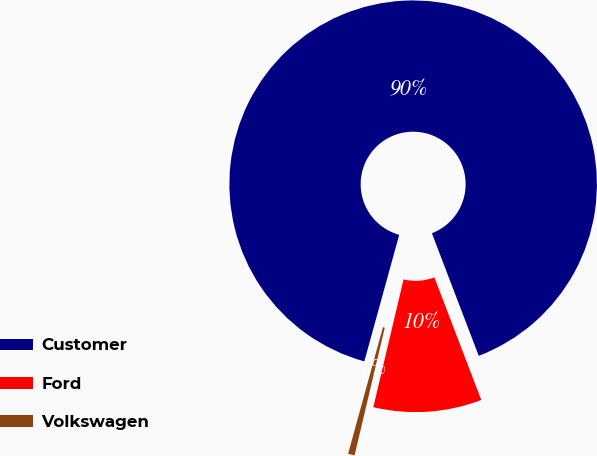Convert chart to OTSL. <chart><loc_0><loc_0><loc_500><loc_500><pie_chart><fcel>Customer<fcel>Ford<fcel>Volkswagen<nl><fcel>89.91%<fcel>9.51%<fcel>0.58%<nl></chart> 